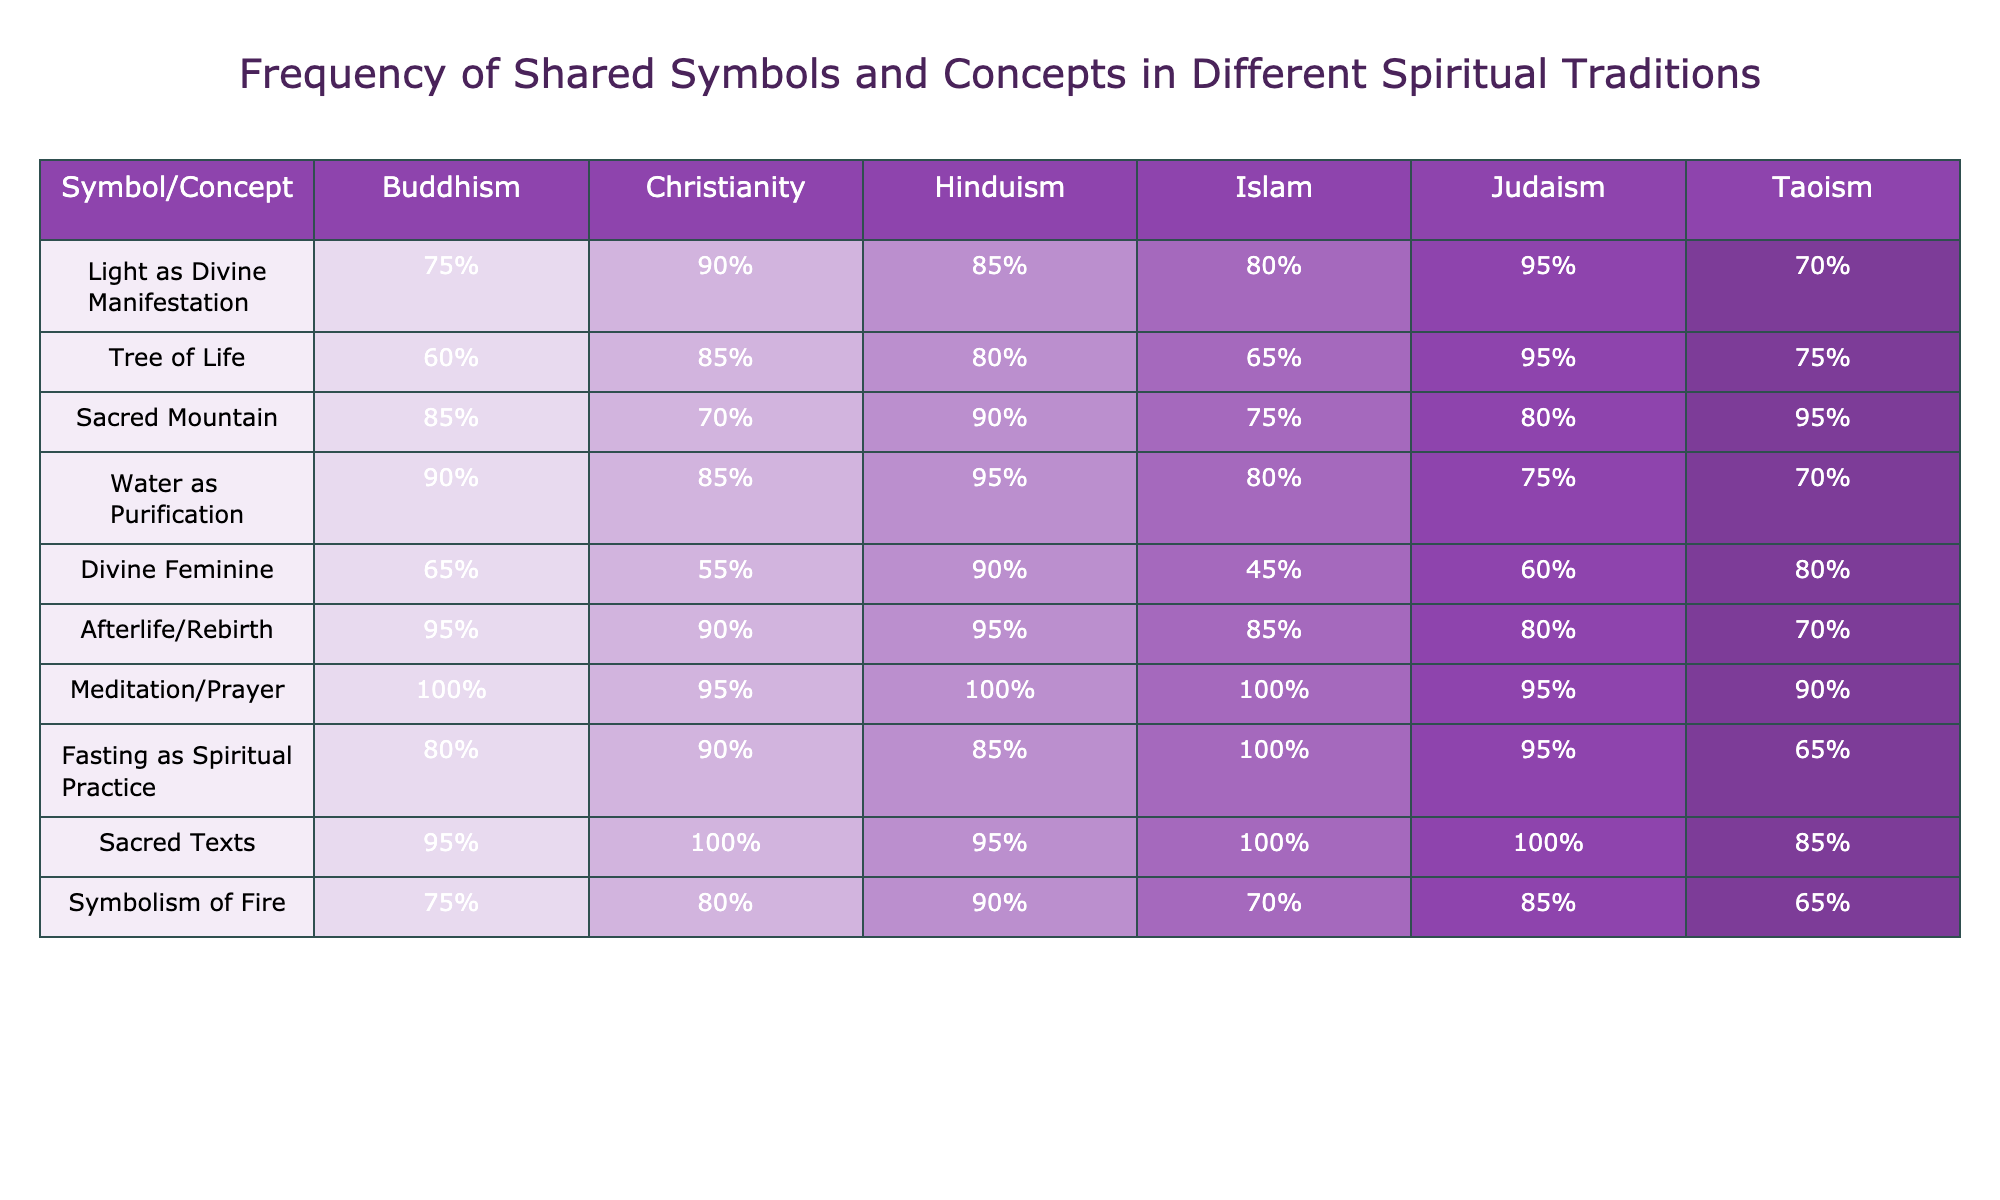What symbol or concept has the highest representation in Buddhism? The highest percentage for Buddhism is for "Meditation/Prayer," which is 100%. This can be directly observed from the table.
Answer: 100% Which spiritual tradition has the lowest percentage for the "Divine Feminine" symbol? The "Divine Feminine" symbol has the lowest percentage in Islam at 45%. This is the smallest number listed for that specific concept among all traditions.
Answer: 45% What is the average percentage of the "Tree of Life" across all traditions? Adding up all the percentages for "Tree of Life" gives (60 + 85 + 80 + 65 + 95 + 75) = 460. There are 6 traditions, so the average is 460 / 6 = approximately 76.67%.
Answer: 76.67% Is "Water as Purification" a concept that all traditions agree on? No, while all traditions have high percentages for "Water as Purification," none have it at 100%. This indicates that there is no unanimous agreement that it is shared among all.
Answer: No What is the difference in percentage for "Fasting as Spiritual Practice" between Christianity and Islam? The percentage for "Fasting as Spiritual Practice" is 90% in Christianity and 100% in Islam. The difference is 100% - 90% = 10%.
Answer: 10% Which concept has the highest frequency among all traditions combined? The "Sacred Texts" concept shows a frequency of 100% in both Christianity and Islam, making it the highest shared concept.
Answer: Sacred Texts What is the representation of "Light as Divine Manifestation" in Hinduism relative to Buddhism? In Hinduism, the percentage for "Light as Divine Manifestation" is 85%, while in Buddhism it is 75%. The representation in Hinduism is 10% higher than in Buddhism.
Answer: 10% higher Are there any symbols or concepts that are universally present among all traditions? Yes, "Meditation/Prayer" and "Sacred Texts" both have a frequency of 100% in multiple traditions, indicating strong universal agreement. However, none are shared by *all* traditions.
Answer: No What is the median value of the "Afterlife/Rebirth" symbol across the traditions? The percentages for "Afterlife/Rebirth" are arranged as (95, 90, 95, 85, 80, 70). The middle values (after ordering) are 85 and 90, so the median is (85 + 90) / 2 = 87.5%.
Answer: 87.5% Which spiritual tradition has the strongest connection to the "Sacred Mountain" concept? Taoism has the strongest connection with 95%. This is the highest percentage among all traditions for the "Sacred Mountain."
Answer: 95% 